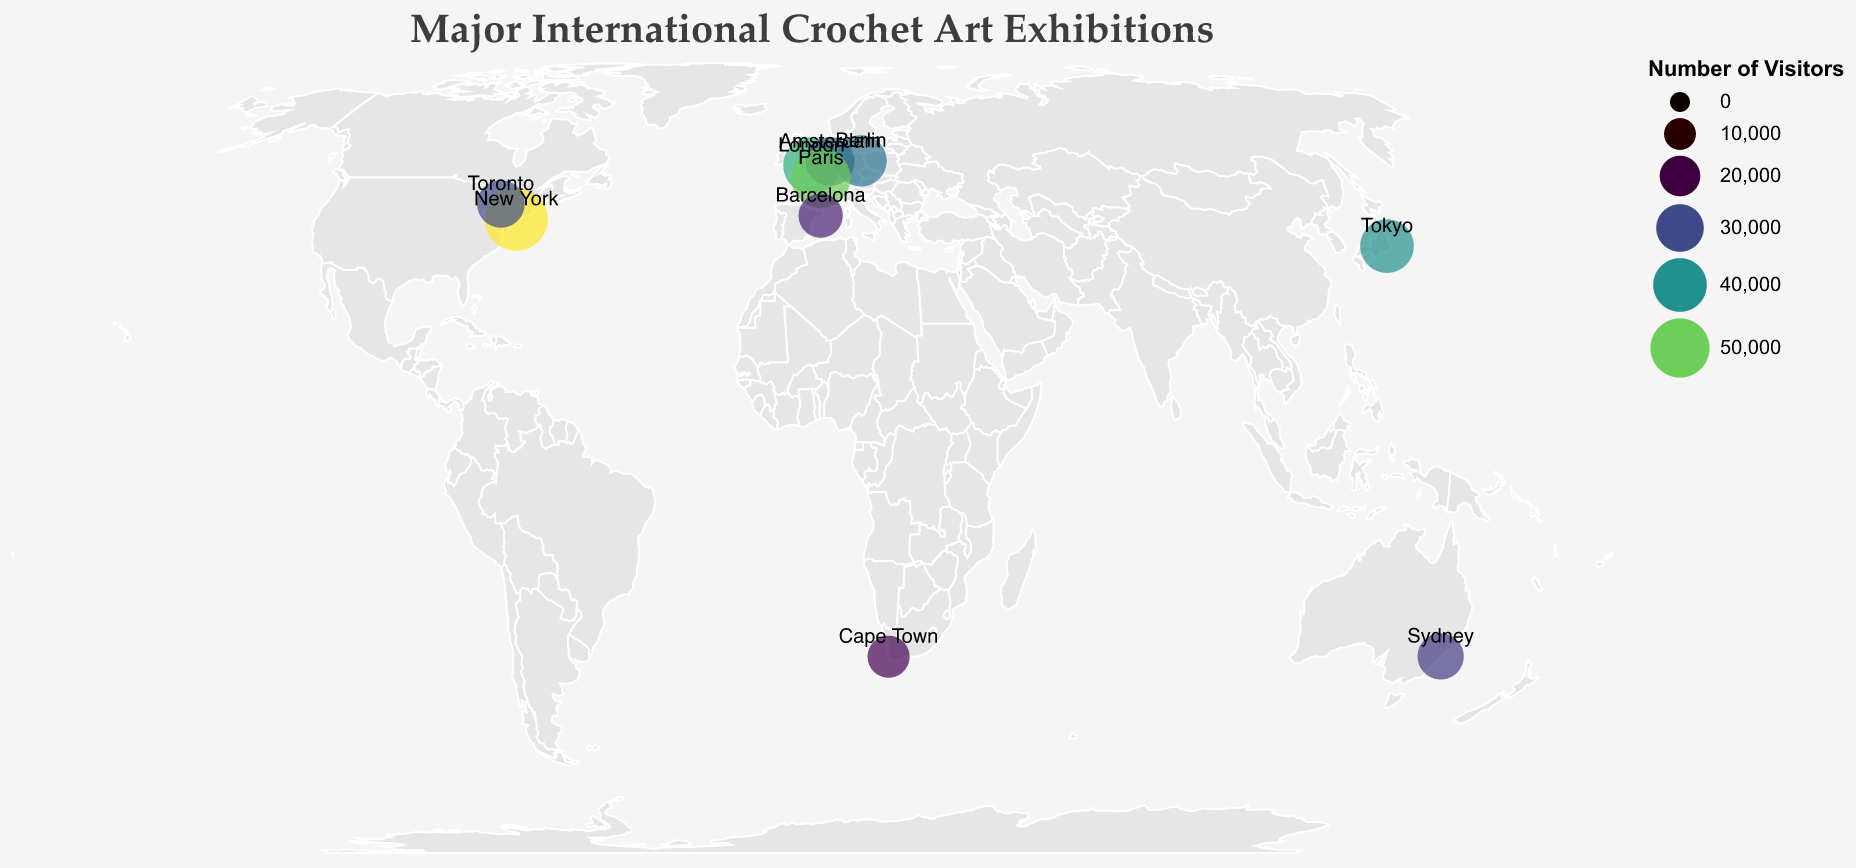Which exhibition had the highest number of visitors? The circles on the map represent the visitor numbers, with larger circles indicating more visitors. The exhibition with the largest circle is in New York.
Answer: Threads of Emotion: Crochet Art from Around the World Which city hosted the "Crochet Couture: Where Art Meets Fashion" exhibition? The map includes text labels for each location and exhibition names in tooltips. Locate the exhibition name "Crochet Couture: Where Art Meets Fashion" from the tooltip to find the city.
Answer: Paris What is the total number of visitors for exhibitions in Europe? Sum the visitor numbers for all European locations: London (45000), Amsterdam (32000), Berlin (36000), Paris (50000), and Barcelona (25000). 45000 + 32000 + 36000 + 50000 + 25000 = 188000
Answer: 188000 Which city had the least number of visitors for its exhibition? On the map, the smallest circle indicates the city with the fewest visitors. The smallest circle is located in Cape Town.
Answer: Cape Town How does the visitor number for "Amigurumi World Showcase" in Tokyo compare to the "North American Crochet Art Festival" in Toronto? From the tooltips, note that "Amigurumi World Showcase" has 40000 visitors and "North American Crochet Art Festival" has 30000 visitors. 40000 is greater than 30000.
Answer: Tokyo has more visitors What's the average number of visitors for the exhibitions in North America? Only New York and Toronto are in North America. Calculate the average: (58000 + 30000) / 2 = 88000 / 2 = 44000
Answer: 44000 What's the common feature of cities that have over 40000 visitors? Check circles larger than 40000 (London, New York, Paris, and Tokyo). These cities are all major global metropolitan centres.
Answer: Major global metropolitan centres How many exhibitions attracted more than 30000 visitors? Count the number of circles with visitor numbers above 30000. From the tooltip data, those are in London, Amsterdam, New York, Tokyo, Berlin, and Paris.
Answer: 6 Which city hosted an exhibition called "Oceanic Crochet Patterns"? Use the map's tooltip feature to locate the specific exhibition title "Oceanic Crochet Patterns." This is found in Sydney.
Answer: Sydney How much larger is the visitor number for the most popular exhibition compared to the least popular exhibition? The most popular exhibition in New York had 58000 visitors, while the least popular in Cape Town had 22000. The difference is 58000 - 22000 = 36000.
Answer: 36000 